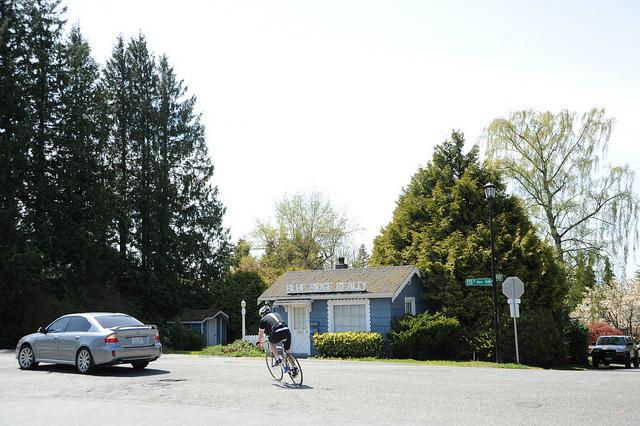What color is the car?
Keep it brief. Silver. What is the boy riding?
Write a very short answer. Bike. What is the man riding near?
Short answer required. Car. Is the road clear?
Write a very short answer. No. Are we in a city?
Write a very short answer. No. Is this a color photograph?
Concise answer only. Yes. Has it rained recently?
Be succinct. No. Who is riding a bike?
Be succinct. Man. Is the bike riding to the left or right?
Write a very short answer. Left. 